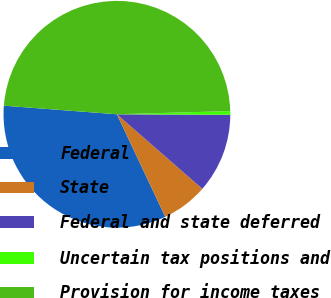Convert chart to OTSL. <chart><loc_0><loc_0><loc_500><loc_500><pie_chart><fcel>Federal<fcel>State<fcel>Federal and state deferred<fcel>Uncertain tax positions and<fcel>Provision for income taxes<nl><fcel>33.22%<fcel>6.57%<fcel>11.35%<fcel>0.52%<fcel>48.34%<nl></chart> 